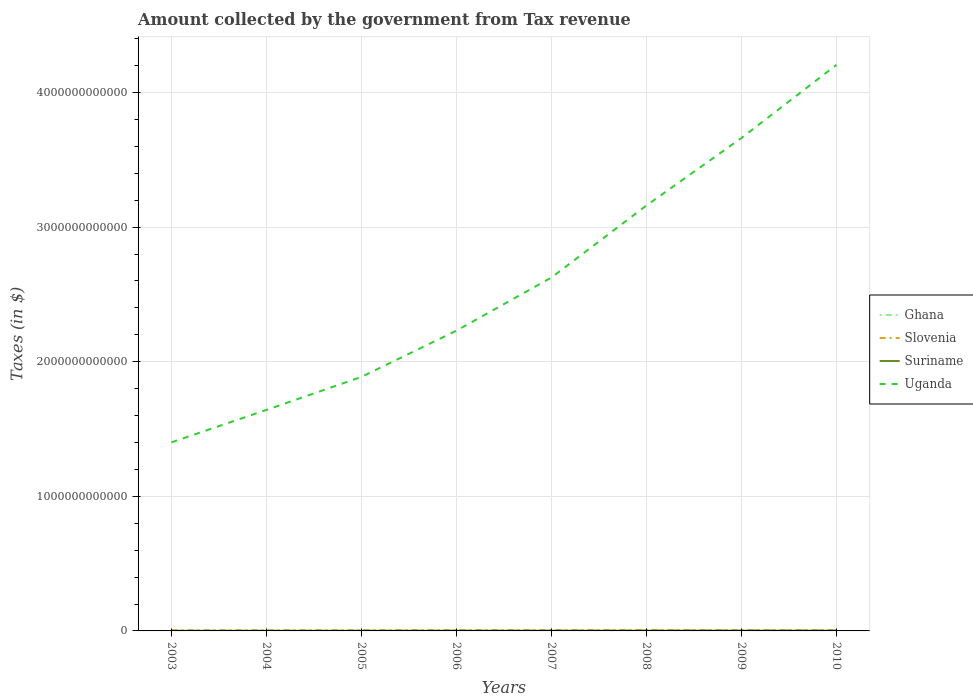Is the number of lines equal to the number of legend labels?
Give a very brief answer. Yes. Across all years, what is the maximum amount collected by the government from tax revenue in Suriname?
Make the answer very short. 7.12e+08. What is the total amount collected by the government from tax revenue in Slovenia in the graph?
Offer a terse response. -1.29e+09. What is the difference between the highest and the second highest amount collected by the government from tax revenue in Uganda?
Ensure brevity in your answer.  2.80e+12. How many years are there in the graph?
Give a very brief answer. 8. What is the difference between two consecutive major ticks on the Y-axis?
Your answer should be compact. 1.00e+12. Are the values on the major ticks of Y-axis written in scientific E-notation?
Offer a terse response. No. Does the graph contain grids?
Give a very brief answer. Yes. What is the title of the graph?
Keep it short and to the point. Amount collected by the government from Tax revenue. Does "Malta" appear as one of the legend labels in the graph?
Offer a terse response. No. What is the label or title of the X-axis?
Keep it short and to the point. Years. What is the label or title of the Y-axis?
Your answer should be very brief. Taxes (in $). What is the Taxes (in $) of Ghana in 2003?
Keep it short and to the point. 1.22e+09. What is the Taxes (in $) of Slovenia in 2003?
Your response must be concise. 5.23e+09. What is the Taxes (in $) of Suriname in 2003?
Provide a short and direct response. 7.12e+08. What is the Taxes (in $) of Uganda in 2003?
Make the answer very short. 1.40e+12. What is the Taxes (in $) in Ghana in 2004?
Provide a short and direct response. 1.74e+09. What is the Taxes (in $) of Slovenia in 2004?
Keep it short and to the point. 5.57e+09. What is the Taxes (in $) in Suriname in 2004?
Keep it short and to the point. 8.53e+08. What is the Taxes (in $) in Uganda in 2004?
Provide a succinct answer. 1.64e+12. What is the Taxes (in $) of Ghana in 2005?
Provide a short and direct response. 2.07e+09. What is the Taxes (in $) of Slovenia in 2005?
Make the answer very short. 5.90e+09. What is the Taxes (in $) of Suriname in 2005?
Your answer should be very brief. 1.01e+09. What is the Taxes (in $) of Uganda in 2005?
Make the answer very short. 1.89e+12. What is the Taxes (in $) of Ghana in 2006?
Your answer should be compact. 2.40e+09. What is the Taxes (in $) of Slovenia in 2006?
Make the answer very short. 6.52e+09. What is the Taxes (in $) of Suriname in 2006?
Provide a succinct answer. 1.21e+09. What is the Taxes (in $) of Uganda in 2006?
Your answer should be compact. 2.23e+12. What is the Taxes (in $) of Ghana in 2007?
Your response must be concise. 3.21e+09. What is the Taxes (in $) in Slovenia in 2007?
Keep it short and to the point. 6.79e+09. What is the Taxes (in $) in Suriname in 2007?
Ensure brevity in your answer.  1.52e+09. What is the Taxes (in $) of Uganda in 2007?
Ensure brevity in your answer.  2.63e+12. What is the Taxes (in $) of Ghana in 2008?
Ensure brevity in your answer.  4.19e+09. What is the Taxes (in $) of Slovenia in 2008?
Ensure brevity in your answer.  7.43e+09. What is the Taxes (in $) in Suriname in 2008?
Your answer should be very brief. 1.68e+09. What is the Taxes (in $) of Uganda in 2008?
Give a very brief answer. 3.16e+12. What is the Taxes (in $) of Ghana in 2009?
Provide a succinct answer. 4.62e+09. What is the Taxes (in $) of Slovenia in 2009?
Offer a terse response. 6.38e+09. What is the Taxes (in $) in Suriname in 2009?
Your answer should be compact. 1.83e+09. What is the Taxes (in $) in Uganda in 2009?
Give a very brief answer. 3.66e+12. What is the Taxes (in $) in Ghana in 2010?
Provide a short and direct response. 6.16e+09. What is the Taxes (in $) of Slovenia in 2010?
Provide a short and direct response. 6.07e+09. What is the Taxes (in $) of Suriname in 2010?
Offer a very short reply. 1.88e+09. What is the Taxes (in $) of Uganda in 2010?
Provide a succinct answer. 4.21e+12. Across all years, what is the maximum Taxes (in $) in Ghana?
Make the answer very short. 6.16e+09. Across all years, what is the maximum Taxes (in $) in Slovenia?
Give a very brief answer. 7.43e+09. Across all years, what is the maximum Taxes (in $) in Suriname?
Ensure brevity in your answer.  1.88e+09. Across all years, what is the maximum Taxes (in $) in Uganda?
Your response must be concise. 4.21e+12. Across all years, what is the minimum Taxes (in $) of Ghana?
Offer a terse response. 1.22e+09. Across all years, what is the minimum Taxes (in $) of Slovenia?
Offer a very short reply. 5.23e+09. Across all years, what is the minimum Taxes (in $) of Suriname?
Your answer should be compact. 7.12e+08. Across all years, what is the minimum Taxes (in $) in Uganda?
Keep it short and to the point. 1.40e+12. What is the total Taxes (in $) in Ghana in the graph?
Ensure brevity in your answer.  2.56e+1. What is the total Taxes (in $) of Slovenia in the graph?
Your response must be concise. 4.99e+1. What is the total Taxes (in $) of Suriname in the graph?
Your answer should be compact. 1.07e+1. What is the total Taxes (in $) of Uganda in the graph?
Offer a very short reply. 2.08e+13. What is the difference between the Taxes (in $) in Ghana in 2003 and that in 2004?
Your answer should be compact. -5.15e+08. What is the difference between the Taxes (in $) in Slovenia in 2003 and that in 2004?
Your answer should be very brief. -3.40e+08. What is the difference between the Taxes (in $) of Suriname in 2003 and that in 2004?
Keep it short and to the point. -1.41e+08. What is the difference between the Taxes (in $) of Uganda in 2003 and that in 2004?
Your answer should be compact. -2.41e+11. What is the difference between the Taxes (in $) of Ghana in 2003 and that in 2005?
Ensure brevity in your answer.  -8.51e+08. What is the difference between the Taxes (in $) of Slovenia in 2003 and that in 2005?
Give a very brief answer. -6.75e+08. What is the difference between the Taxes (in $) in Suriname in 2003 and that in 2005?
Your answer should be compact. -2.95e+08. What is the difference between the Taxes (in $) in Uganda in 2003 and that in 2005?
Offer a terse response. -4.86e+11. What is the difference between the Taxes (in $) in Ghana in 2003 and that in 2006?
Provide a short and direct response. -1.17e+09. What is the difference between the Taxes (in $) in Slovenia in 2003 and that in 2006?
Give a very brief answer. -1.29e+09. What is the difference between the Taxes (in $) in Suriname in 2003 and that in 2006?
Provide a short and direct response. -4.95e+08. What is the difference between the Taxes (in $) in Uganda in 2003 and that in 2006?
Your answer should be compact. -8.30e+11. What is the difference between the Taxes (in $) of Ghana in 2003 and that in 2007?
Give a very brief answer. -1.99e+09. What is the difference between the Taxes (in $) in Slovenia in 2003 and that in 2007?
Give a very brief answer. -1.57e+09. What is the difference between the Taxes (in $) of Suriname in 2003 and that in 2007?
Your response must be concise. -8.09e+08. What is the difference between the Taxes (in $) in Uganda in 2003 and that in 2007?
Your answer should be very brief. -1.22e+12. What is the difference between the Taxes (in $) in Ghana in 2003 and that in 2008?
Make the answer very short. -2.97e+09. What is the difference between the Taxes (in $) in Slovenia in 2003 and that in 2008?
Keep it short and to the point. -2.20e+09. What is the difference between the Taxes (in $) in Suriname in 2003 and that in 2008?
Offer a terse response. -9.70e+08. What is the difference between the Taxes (in $) of Uganda in 2003 and that in 2008?
Give a very brief answer. -1.76e+12. What is the difference between the Taxes (in $) of Ghana in 2003 and that in 2009?
Your answer should be compact. -3.39e+09. What is the difference between the Taxes (in $) of Slovenia in 2003 and that in 2009?
Keep it short and to the point. -1.16e+09. What is the difference between the Taxes (in $) in Suriname in 2003 and that in 2009?
Your answer should be compact. -1.12e+09. What is the difference between the Taxes (in $) of Uganda in 2003 and that in 2009?
Ensure brevity in your answer.  -2.26e+12. What is the difference between the Taxes (in $) in Ghana in 2003 and that in 2010?
Keep it short and to the point. -4.94e+09. What is the difference between the Taxes (in $) of Slovenia in 2003 and that in 2010?
Your response must be concise. -8.41e+08. What is the difference between the Taxes (in $) in Suriname in 2003 and that in 2010?
Offer a very short reply. -1.17e+09. What is the difference between the Taxes (in $) in Uganda in 2003 and that in 2010?
Provide a short and direct response. -2.80e+12. What is the difference between the Taxes (in $) in Ghana in 2004 and that in 2005?
Make the answer very short. -3.36e+08. What is the difference between the Taxes (in $) in Slovenia in 2004 and that in 2005?
Give a very brief answer. -3.34e+08. What is the difference between the Taxes (in $) in Suriname in 2004 and that in 2005?
Offer a terse response. -1.54e+08. What is the difference between the Taxes (in $) of Uganda in 2004 and that in 2005?
Your answer should be compact. -2.45e+11. What is the difference between the Taxes (in $) in Ghana in 2004 and that in 2006?
Give a very brief answer. -6.58e+08. What is the difference between the Taxes (in $) of Slovenia in 2004 and that in 2006?
Your answer should be very brief. -9.53e+08. What is the difference between the Taxes (in $) in Suriname in 2004 and that in 2006?
Provide a short and direct response. -3.54e+08. What is the difference between the Taxes (in $) of Uganda in 2004 and that in 2006?
Provide a succinct answer. -5.89e+11. What is the difference between the Taxes (in $) in Ghana in 2004 and that in 2007?
Make the answer very short. -1.48e+09. What is the difference between the Taxes (in $) in Slovenia in 2004 and that in 2007?
Ensure brevity in your answer.  -1.23e+09. What is the difference between the Taxes (in $) in Suriname in 2004 and that in 2007?
Your answer should be very brief. -6.68e+08. What is the difference between the Taxes (in $) of Uganda in 2004 and that in 2007?
Provide a succinct answer. -9.84e+11. What is the difference between the Taxes (in $) in Ghana in 2004 and that in 2008?
Provide a succinct answer. -2.46e+09. What is the difference between the Taxes (in $) in Slovenia in 2004 and that in 2008?
Offer a terse response. -1.86e+09. What is the difference between the Taxes (in $) in Suriname in 2004 and that in 2008?
Make the answer very short. -8.29e+08. What is the difference between the Taxes (in $) of Uganda in 2004 and that in 2008?
Keep it short and to the point. -1.52e+12. What is the difference between the Taxes (in $) in Ghana in 2004 and that in 2009?
Ensure brevity in your answer.  -2.88e+09. What is the difference between the Taxes (in $) of Slovenia in 2004 and that in 2009?
Your response must be concise. -8.16e+08. What is the difference between the Taxes (in $) in Suriname in 2004 and that in 2009?
Your response must be concise. -9.79e+08. What is the difference between the Taxes (in $) of Uganda in 2004 and that in 2009?
Offer a very short reply. -2.02e+12. What is the difference between the Taxes (in $) of Ghana in 2004 and that in 2010?
Provide a succinct answer. -4.43e+09. What is the difference between the Taxes (in $) of Slovenia in 2004 and that in 2010?
Your answer should be compact. -5.00e+08. What is the difference between the Taxes (in $) in Suriname in 2004 and that in 2010?
Ensure brevity in your answer.  -1.02e+09. What is the difference between the Taxes (in $) in Uganda in 2004 and that in 2010?
Ensure brevity in your answer.  -2.56e+12. What is the difference between the Taxes (in $) in Ghana in 2005 and that in 2006?
Your response must be concise. -3.22e+08. What is the difference between the Taxes (in $) in Slovenia in 2005 and that in 2006?
Give a very brief answer. -6.18e+08. What is the difference between the Taxes (in $) of Suriname in 2005 and that in 2006?
Offer a very short reply. -2.00e+08. What is the difference between the Taxes (in $) in Uganda in 2005 and that in 2006?
Provide a short and direct response. -3.44e+11. What is the difference between the Taxes (in $) of Ghana in 2005 and that in 2007?
Provide a short and direct response. -1.14e+09. What is the difference between the Taxes (in $) in Slovenia in 2005 and that in 2007?
Ensure brevity in your answer.  -8.91e+08. What is the difference between the Taxes (in $) of Suriname in 2005 and that in 2007?
Your answer should be very brief. -5.14e+08. What is the difference between the Taxes (in $) of Uganda in 2005 and that in 2007?
Make the answer very short. -7.38e+11. What is the difference between the Taxes (in $) in Ghana in 2005 and that in 2008?
Provide a succinct answer. -2.12e+09. What is the difference between the Taxes (in $) of Slovenia in 2005 and that in 2008?
Your answer should be very brief. -1.53e+09. What is the difference between the Taxes (in $) in Suriname in 2005 and that in 2008?
Give a very brief answer. -6.76e+08. What is the difference between the Taxes (in $) of Uganda in 2005 and that in 2008?
Ensure brevity in your answer.  -1.27e+12. What is the difference between the Taxes (in $) in Ghana in 2005 and that in 2009?
Offer a terse response. -2.54e+09. What is the difference between the Taxes (in $) of Slovenia in 2005 and that in 2009?
Make the answer very short. -4.81e+08. What is the difference between the Taxes (in $) in Suriname in 2005 and that in 2009?
Keep it short and to the point. -8.25e+08. What is the difference between the Taxes (in $) of Uganda in 2005 and that in 2009?
Keep it short and to the point. -1.77e+12. What is the difference between the Taxes (in $) of Ghana in 2005 and that in 2010?
Keep it short and to the point. -4.09e+09. What is the difference between the Taxes (in $) of Slovenia in 2005 and that in 2010?
Offer a terse response. -1.66e+08. What is the difference between the Taxes (in $) in Suriname in 2005 and that in 2010?
Provide a succinct answer. -8.71e+08. What is the difference between the Taxes (in $) of Uganda in 2005 and that in 2010?
Ensure brevity in your answer.  -2.32e+12. What is the difference between the Taxes (in $) in Ghana in 2006 and that in 2007?
Offer a terse response. -8.18e+08. What is the difference between the Taxes (in $) of Slovenia in 2006 and that in 2007?
Your response must be concise. -2.73e+08. What is the difference between the Taxes (in $) in Suriname in 2006 and that in 2007?
Your answer should be very brief. -3.14e+08. What is the difference between the Taxes (in $) in Uganda in 2006 and that in 2007?
Your answer should be very brief. -3.95e+11. What is the difference between the Taxes (in $) of Ghana in 2006 and that in 2008?
Make the answer very short. -1.80e+09. What is the difference between the Taxes (in $) of Slovenia in 2006 and that in 2008?
Offer a terse response. -9.12e+08. What is the difference between the Taxes (in $) of Suriname in 2006 and that in 2008?
Give a very brief answer. -4.76e+08. What is the difference between the Taxes (in $) in Uganda in 2006 and that in 2008?
Your answer should be compact. -9.30e+11. What is the difference between the Taxes (in $) in Ghana in 2006 and that in 2009?
Keep it short and to the point. -2.22e+09. What is the difference between the Taxes (in $) of Slovenia in 2006 and that in 2009?
Provide a short and direct response. 1.37e+08. What is the difference between the Taxes (in $) of Suriname in 2006 and that in 2009?
Give a very brief answer. -6.25e+08. What is the difference between the Taxes (in $) of Uganda in 2006 and that in 2009?
Ensure brevity in your answer.  -1.43e+12. What is the difference between the Taxes (in $) of Ghana in 2006 and that in 2010?
Your answer should be compact. -3.77e+09. What is the difference between the Taxes (in $) of Slovenia in 2006 and that in 2010?
Your answer should be very brief. 4.52e+08. What is the difference between the Taxes (in $) of Suriname in 2006 and that in 2010?
Offer a terse response. -6.71e+08. What is the difference between the Taxes (in $) in Uganda in 2006 and that in 2010?
Your response must be concise. -1.97e+12. What is the difference between the Taxes (in $) of Ghana in 2007 and that in 2008?
Your answer should be compact. -9.80e+08. What is the difference between the Taxes (in $) of Slovenia in 2007 and that in 2008?
Give a very brief answer. -6.39e+08. What is the difference between the Taxes (in $) of Suriname in 2007 and that in 2008?
Your answer should be compact. -1.62e+08. What is the difference between the Taxes (in $) of Uganda in 2007 and that in 2008?
Offer a terse response. -5.35e+11. What is the difference between the Taxes (in $) of Ghana in 2007 and that in 2009?
Your answer should be very brief. -1.40e+09. What is the difference between the Taxes (in $) of Slovenia in 2007 and that in 2009?
Make the answer very short. 4.10e+08. What is the difference between the Taxes (in $) in Suriname in 2007 and that in 2009?
Ensure brevity in your answer.  -3.11e+08. What is the difference between the Taxes (in $) in Uganda in 2007 and that in 2009?
Offer a terse response. -1.04e+12. What is the difference between the Taxes (in $) in Ghana in 2007 and that in 2010?
Your response must be concise. -2.95e+09. What is the difference between the Taxes (in $) of Slovenia in 2007 and that in 2010?
Make the answer very short. 7.25e+08. What is the difference between the Taxes (in $) of Suriname in 2007 and that in 2010?
Your answer should be very brief. -3.57e+08. What is the difference between the Taxes (in $) of Uganda in 2007 and that in 2010?
Your answer should be compact. -1.58e+12. What is the difference between the Taxes (in $) in Ghana in 2008 and that in 2009?
Provide a succinct answer. -4.22e+08. What is the difference between the Taxes (in $) in Slovenia in 2008 and that in 2009?
Your answer should be very brief. 1.05e+09. What is the difference between the Taxes (in $) in Suriname in 2008 and that in 2009?
Offer a terse response. -1.49e+08. What is the difference between the Taxes (in $) in Uganda in 2008 and that in 2009?
Your response must be concise. -5.01e+11. What is the difference between the Taxes (in $) of Ghana in 2008 and that in 2010?
Ensure brevity in your answer.  -1.97e+09. What is the difference between the Taxes (in $) of Slovenia in 2008 and that in 2010?
Your response must be concise. 1.36e+09. What is the difference between the Taxes (in $) in Suriname in 2008 and that in 2010?
Your answer should be compact. -1.95e+08. What is the difference between the Taxes (in $) of Uganda in 2008 and that in 2010?
Give a very brief answer. -1.04e+12. What is the difference between the Taxes (in $) in Ghana in 2009 and that in 2010?
Give a very brief answer. -1.55e+09. What is the difference between the Taxes (in $) in Slovenia in 2009 and that in 2010?
Your answer should be compact. 3.15e+08. What is the difference between the Taxes (in $) of Suriname in 2009 and that in 2010?
Your answer should be compact. -4.60e+07. What is the difference between the Taxes (in $) of Uganda in 2009 and that in 2010?
Keep it short and to the point. -5.43e+11. What is the difference between the Taxes (in $) in Ghana in 2003 and the Taxes (in $) in Slovenia in 2004?
Offer a terse response. -4.34e+09. What is the difference between the Taxes (in $) in Ghana in 2003 and the Taxes (in $) in Suriname in 2004?
Give a very brief answer. 3.69e+08. What is the difference between the Taxes (in $) in Ghana in 2003 and the Taxes (in $) in Uganda in 2004?
Your answer should be very brief. -1.64e+12. What is the difference between the Taxes (in $) of Slovenia in 2003 and the Taxes (in $) of Suriname in 2004?
Offer a terse response. 4.37e+09. What is the difference between the Taxes (in $) of Slovenia in 2003 and the Taxes (in $) of Uganda in 2004?
Your response must be concise. -1.64e+12. What is the difference between the Taxes (in $) in Suriname in 2003 and the Taxes (in $) in Uganda in 2004?
Offer a very short reply. -1.64e+12. What is the difference between the Taxes (in $) of Ghana in 2003 and the Taxes (in $) of Slovenia in 2005?
Keep it short and to the point. -4.68e+09. What is the difference between the Taxes (in $) in Ghana in 2003 and the Taxes (in $) in Suriname in 2005?
Your answer should be compact. 2.16e+08. What is the difference between the Taxes (in $) of Ghana in 2003 and the Taxes (in $) of Uganda in 2005?
Ensure brevity in your answer.  -1.89e+12. What is the difference between the Taxes (in $) in Slovenia in 2003 and the Taxes (in $) in Suriname in 2005?
Give a very brief answer. 4.22e+09. What is the difference between the Taxes (in $) in Slovenia in 2003 and the Taxes (in $) in Uganda in 2005?
Keep it short and to the point. -1.88e+12. What is the difference between the Taxes (in $) in Suriname in 2003 and the Taxes (in $) in Uganda in 2005?
Ensure brevity in your answer.  -1.89e+12. What is the difference between the Taxes (in $) in Ghana in 2003 and the Taxes (in $) in Slovenia in 2006?
Your answer should be compact. -5.30e+09. What is the difference between the Taxes (in $) in Ghana in 2003 and the Taxes (in $) in Suriname in 2006?
Ensure brevity in your answer.  1.55e+07. What is the difference between the Taxes (in $) of Ghana in 2003 and the Taxes (in $) of Uganda in 2006?
Offer a very short reply. -2.23e+12. What is the difference between the Taxes (in $) in Slovenia in 2003 and the Taxes (in $) in Suriname in 2006?
Provide a succinct answer. 4.02e+09. What is the difference between the Taxes (in $) of Slovenia in 2003 and the Taxes (in $) of Uganda in 2006?
Ensure brevity in your answer.  -2.23e+12. What is the difference between the Taxes (in $) in Suriname in 2003 and the Taxes (in $) in Uganda in 2006?
Offer a terse response. -2.23e+12. What is the difference between the Taxes (in $) of Ghana in 2003 and the Taxes (in $) of Slovenia in 2007?
Your response must be concise. -5.57e+09. What is the difference between the Taxes (in $) of Ghana in 2003 and the Taxes (in $) of Suriname in 2007?
Provide a short and direct response. -2.98e+08. What is the difference between the Taxes (in $) in Ghana in 2003 and the Taxes (in $) in Uganda in 2007?
Give a very brief answer. -2.62e+12. What is the difference between the Taxes (in $) of Slovenia in 2003 and the Taxes (in $) of Suriname in 2007?
Your answer should be compact. 3.70e+09. What is the difference between the Taxes (in $) of Slovenia in 2003 and the Taxes (in $) of Uganda in 2007?
Provide a short and direct response. -2.62e+12. What is the difference between the Taxes (in $) of Suriname in 2003 and the Taxes (in $) of Uganda in 2007?
Your answer should be very brief. -2.63e+12. What is the difference between the Taxes (in $) in Ghana in 2003 and the Taxes (in $) in Slovenia in 2008?
Make the answer very short. -6.21e+09. What is the difference between the Taxes (in $) of Ghana in 2003 and the Taxes (in $) of Suriname in 2008?
Make the answer very short. -4.60e+08. What is the difference between the Taxes (in $) of Ghana in 2003 and the Taxes (in $) of Uganda in 2008?
Offer a terse response. -3.16e+12. What is the difference between the Taxes (in $) of Slovenia in 2003 and the Taxes (in $) of Suriname in 2008?
Make the answer very short. 3.54e+09. What is the difference between the Taxes (in $) of Slovenia in 2003 and the Taxes (in $) of Uganda in 2008?
Offer a terse response. -3.16e+12. What is the difference between the Taxes (in $) of Suriname in 2003 and the Taxes (in $) of Uganda in 2008?
Offer a very short reply. -3.16e+12. What is the difference between the Taxes (in $) of Ghana in 2003 and the Taxes (in $) of Slovenia in 2009?
Offer a very short reply. -5.16e+09. What is the difference between the Taxes (in $) of Ghana in 2003 and the Taxes (in $) of Suriname in 2009?
Provide a succinct answer. -6.09e+08. What is the difference between the Taxes (in $) of Ghana in 2003 and the Taxes (in $) of Uganda in 2009?
Offer a very short reply. -3.66e+12. What is the difference between the Taxes (in $) in Slovenia in 2003 and the Taxes (in $) in Suriname in 2009?
Provide a succinct answer. 3.39e+09. What is the difference between the Taxes (in $) of Slovenia in 2003 and the Taxes (in $) of Uganda in 2009?
Make the answer very short. -3.66e+12. What is the difference between the Taxes (in $) in Suriname in 2003 and the Taxes (in $) in Uganda in 2009?
Your answer should be very brief. -3.66e+12. What is the difference between the Taxes (in $) in Ghana in 2003 and the Taxes (in $) in Slovenia in 2010?
Make the answer very short. -4.84e+09. What is the difference between the Taxes (in $) in Ghana in 2003 and the Taxes (in $) in Suriname in 2010?
Your answer should be very brief. -6.55e+08. What is the difference between the Taxes (in $) of Ghana in 2003 and the Taxes (in $) of Uganda in 2010?
Make the answer very short. -4.20e+12. What is the difference between the Taxes (in $) of Slovenia in 2003 and the Taxes (in $) of Suriname in 2010?
Your answer should be compact. 3.35e+09. What is the difference between the Taxes (in $) in Slovenia in 2003 and the Taxes (in $) in Uganda in 2010?
Give a very brief answer. -4.20e+12. What is the difference between the Taxes (in $) in Suriname in 2003 and the Taxes (in $) in Uganda in 2010?
Provide a short and direct response. -4.20e+12. What is the difference between the Taxes (in $) of Ghana in 2004 and the Taxes (in $) of Slovenia in 2005?
Keep it short and to the point. -4.16e+09. What is the difference between the Taxes (in $) in Ghana in 2004 and the Taxes (in $) in Suriname in 2005?
Offer a terse response. 7.31e+08. What is the difference between the Taxes (in $) of Ghana in 2004 and the Taxes (in $) of Uganda in 2005?
Make the answer very short. -1.89e+12. What is the difference between the Taxes (in $) of Slovenia in 2004 and the Taxes (in $) of Suriname in 2005?
Provide a succinct answer. 4.56e+09. What is the difference between the Taxes (in $) of Slovenia in 2004 and the Taxes (in $) of Uganda in 2005?
Offer a very short reply. -1.88e+12. What is the difference between the Taxes (in $) in Suriname in 2004 and the Taxes (in $) in Uganda in 2005?
Give a very brief answer. -1.89e+12. What is the difference between the Taxes (in $) of Ghana in 2004 and the Taxes (in $) of Slovenia in 2006?
Make the answer very short. -4.78e+09. What is the difference between the Taxes (in $) in Ghana in 2004 and the Taxes (in $) in Suriname in 2006?
Ensure brevity in your answer.  5.31e+08. What is the difference between the Taxes (in $) in Ghana in 2004 and the Taxes (in $) in Uganda in 2006?
Your answer should be compact. -2.23e+12. What is the difference between the Taxes (in $) in Slovenia in 2004 and the Taxes (in $) in Suriname in 2006?
Provide a succinct answer. 4.36e+09. What is the difference between the Taxes (in $) of Slovenia in 2004 and the Taxes (in $) of Uganda in 2006?
Your answer should be very brief. -2.23e+12. What is the difference between the Taxes (in $) of Suriname in 2004 and the Taxes (in $) of Uganda in 2006?
Make the answer very short. -2.23e+12. What is the difference between the Taxes (in $) of Ghana in 2004 and the Taxes (in $) of Slovenia in 2007?
Give a very brief answer. -5.05e+09. What is the difference between the Taxes (in $) in Ghana in 2004 and the Taxes (in $) in Suriname in 2007?
Your response must be concise. 2.17e+08. What is the difference between the Taxes (in $) in Ghana in 2004 and the Taxes (in $) in Uganda in 2007?
Provide a succinct answer. -2.62e+12. What is the difference between the Taxes (in $) of Slovenia in 2004 and the Taxes (in $) of Suriname in 2007?
Provide a short and direct response. 4.04e+09. What is the difference between the Taxes (in $) of Slovenia in 2004 and the Taxes (in $) of Uganda in 2007?
Give a very brief answer. -2.62e+12. What is the difference between the Taxes (in $) in Suriname in 2004 and the Taxes (in $) in Uganda in 2007?
Your answer should be very brief. -2.62e+12. What is the difference between the Taxes (in $) of Ghana in 2004 and the Taxes (in $) of Slovenia in 2008?
Make the answer very short. -5.69e+09. What is the difference between the Taxes (in $) in Ghana in 2004 and the Taxes (in $) in Suriname in 2008?
Your answer should be very brief. 5.52e+07. What is the difference between the Taxes (in $) of Ghana in 2004 and the Taxes (in $) of Uganda in 2008?
Offer a terse response. -3.16e+12. What is the difference between the Taxes (in $) of Slovenia in 2004 and the Taxes (in $) of Suriname in 2008?
Your answer should be compact. 3.88e+09. What is the difference between the Taxes (in $) in Slovenia in 2004 and the Taxes (in $) in Uganda in 2008?
Provide a short and direct response. -3.16e+12. What is the difference between the Taxes (in $) of Suriname in 2004 and the Taxes (in $) of Uganda in 2008?
Your response must be concise. -3.16e+12. What is the difference between the Taxes (in $) of Ghana in 2004 and the Taxes (in $) of Slovenia in 2009?
Provide a short and direct response. -4.64e+09. What is the difference between the Taxes (in $) of Ghana in 2004 and the Taxes (in $) of Suriname in 2009?
Give a very brief answer. -9.40e+07. What is the difference between the Taxes (in $) in Ghana in 2004 and the Taxes (in $) in Uganda in 2009?
Your answer should be compact. -3.66e+12. What is the difference between the Taxes (in $) in Slovenia in 2004 and the Taxes (in $) in Suriname in 2009?
Provide a succinct answer. 3.73e+09. What is the difference between the Taxes (in $) in Slovenia in 2004 and the Taxes (in $) in Uganda in 2009?
Your response must be concise. -3.66e+12. What is the difference between the Taxes (in $) in Suriname in 2004 and the Taxes (in $) in Uganda in 2009?
Offer a very short reply. -3.66e+12. What is the difference between the Taxes (in $) of Ghana in 2004 and the Taxes (in $) of Slovenia in 2010?
Your answer should be compact. -4.33e+09. What is the difference between the Taxes (in $) of Ghana in 2004 and the Taxes (in $) of Suriname in 2010?
Your answer should be very brief. -1.40e+08. What is the difference between the Taxes (in $) in Ghana in 2004 and the Taxes (in $) in Uganda in 2010?
Keep it short and to the point. -4.20e+12. What is the difference between the Taxes (in $) in Slovenia in 2004 and the Taxes (in $) in Suriname in 2010?
Your answer should be very brief. 3.69e+09. What is the difference between the Taxes (in $) in Slovenia in 2004 and the Taxes (in $) in Uganda in 2010?
Offer a terse response. -4.20e+12. What is the difference between the Taxes (in $) in Suriname in 2004 and the Taxes (in $) in Uganda in 2010?
Ensure brevity in your answer.  -4.20e+12. What is the difference between the Taxes (in $) of Ghana in 2005 and the Taxes (in $) of Slovenia in 2006?
Your answer should be very brief. -4.44e+09. What is the difference between the Taxes (in $) of Ghana in 2005 and the Taxes (in $) of Suriname in 2006?
Make the answer very short. 8.67e+08. What is the difference between the Taxes (in $) in Ghana in 2005 and the Taxes (in $) in Uganda in 2006?
Provide a succinct answer. -2.23e+12. What is the difference between the Taxes (in $) in Slovenia in 2005 and the Taxes (in $) in Suriname in 2006?
Ensure brevity in your answer.  4.69e+09. What is the difference between the Taxes (in $) of Slovenia in 2005 and the Taxes (in $) of Uganda in 2006?
Keep it short and to the point. -2.23e+12. What is the difference between the Taxes (in $) of Suriname in 2005 and the Taxes (in $) of Uganda in 2006?
Provide a short and direct response. -2.23e+12. What is the difference between the Taxes (in $) in Ghana in 2005 and the Taxes (in $) in Slovenia in 2007?
Your answer should be very brief. -4.72e+09. What is the difference between the Taxes (in $) of Ghana in 2005 and the Taxes (in $) of Suriname in 2007?
Your answer should be compact. 5.53e+08. What is the difference between the Taxes (in $) of Ghana in 2005 and the Taxes (in $) of Uganda in 2007?
Keep it short and to the point. -2.62e+12. What is the difference between the Taxes (in $) of Slovenia in 2005 and the Taxes (in $) of Suriname in 2007?
Keep it short and to the point. 4.38e+09. What is the difference between the Taxes (in $) of Slovenia in 2005 and the Taxes (in $) of Uganda in 2007?
Offer a terse response. -2.62e+12. What is the difference between the Taxes (in $) of Suriname in 2005 and the Taxes (in $) of Uganda in 2007?
Offer a terse response. -2.62e+12. What is the difference between the Taxes (in $) of Ghana in 2005 and the Taxes (in $) of Slovenia in 2008?
Offer a terse response. -5.36e+09. What is the difference between the Taxes (in $) of Ghana in 2005 and the Taxes (in $) of Suriname in 2008?
Keep it short and to the point. 3.91e+08. What is the difference between the Taxes (in $) of Ghana in 2005 and the Taxes (in $) of Uganda in 2008?
Your answer should be compact. -3.16e+12. What is the difference between the Taxes (in $) of Slovenia in 2005 and the Taxes (in $) of Suriname in 2008?
Offer a very short reply. 4.22e+09. What is the difference between the Taxes (in $) of Slovenia in 2005 and the Taxes (in $) of Uganda in 2008?
Keep it short and to the point. -3.16e+12. What is the difference between the Taxes (in $) of Suriname in 2005 and the Taxes (in $) of Uganda in 2008?
Give a very brief answer. -3.16e+12. What is the difference between the Taxes (in $) of Ghana in 2005 and the Taxes (in $) of Slovenia in 2009?
Your answer should be compact. -4.31e+09. What is the difference between the Taxes (in $) of Ghana in 2005 and the Taxes (in $) of Suriname in 2009?
Your answer should be compact. 2.42e+08. What is the difference between the Taxes (in $) in Ghana in 2005 and the Taxes (in $) in Uganda in 2009?
Keep it short and to the point. -3.66e+12. What is the difference between the Taxes (in $) of Slovenia in 2005 and the Taxes (in $) of Suriname in 2009?
Offer a very short reply. 4.07e+09. What is the difference between the Taxes (in $) of Slovenia in 2005 and the Taxes (in $) of Uganda in 2009?
Make the answer very short. -3.66e+12. What is the difference between the Taxes (in $) of Suriname in 2005 and the Taxes (in $) of Uganda in 2009?
Provide a short and direct response. -3.66e+12. What is the difference between the Taxes (in $) of Ghana in 2005 and the Taxes (in $) of Slovenia in 2010?
Your answer should be very brief. -3.99e+09. What is the difference between the Taxes (in $) of Ghana in 2005 and the Taxes (in $) of Suriname in 2010?
Provide a succinct answer. 1.96e+08. What is the difference between the Taxes (in $) in Ghana in 2005 and the Taxes (in $) in Uganda in 2010?
Your answer should be compact. -4.20e+12. What is the difference between the Taxes (in $) in Slovenia in 2005 and the Taxes (in $) in Suriname in 2010?
Offer a terse response. 4.02e+09. What is the difference between the Taxes (in $) in Slovenia in 2005 and the Taxes (in $) in Uganda in 2010?
Provide a short and direct response. -4.20e+12. What is the difference between the Taxes (in $) of Suriname in 2005 and the Taxes (in $) of Uganda in 2010?
Make the answer very short. -4.20e+12. What is the difference between the Taxes (in $) in Ghana in 2006 and the Taxes (in $) in Slovenia in 2007?
Offer a very short reply. -4.40e+09. What is the difference between the Taxes (in $) in Ghana in 2006 and the Taxes (in $) in Suriname in 2007?
Give a very brief answer. 8.75e+08. What is the difference between the Taxes (in $) of Ghana in 2006 and the Taxes (in $) of Uganda in 2007?
Offer a terse response. -2.62e+12. What is the difference between the Taxes (in $) in Slovenia in 2006 and the Taxes (in $) in Suriname in 2007?
Make the answer very short. 5.00e+09. What is the difference between the Taxes (in $) in Slovenia in 2006 and the Taxes (in $) in Uganda in 2007?
Offer a very short reply. -2.62e+12. What is the difference between the Taxes (in $) of Suriname in 2006 and the Taxes (in $) of Uganda in 2007?
Keep it short and to the point. -2.62e+12. What is the difference between the Taxes (in $) in Ghana in 2006 and the Taxes (in $) in Slovenia in 2008?
Give a very brief answer. -5.03e+09. What is the difference between the Taxes (in $) in Ghana in 2006 and the Taxes (in $) in Suriname in 2008?
Provide a short and direct response. 7.13e+08. What is the difference between the Taxes (in $) of Ghana in 2006 and the Taxes (in $) of Uganda in 2008?
Offer a terse response. -3.16e+12. What is the difference between the Taxes (in $) of Slovenia in 2006 and the Taxes (in $) of Suriname in 2008?
Ensure brevity in your answer.  4.84e+09. What is the difference between the Taxes (in $) of Slovenia in 2006 and the Taxes (in $) of Uganda in 2008?
Your answer should be very brief. -3.15e+12. What is the difference between the Taxes (in $) of Suriname in 2006 and the Taxes (in $) of Uganda in 2008?
Keep it short and to the point. -3.16e+12. What is the difference between the Taxes (in $) of Ghana in 2006 and the Taxes (in $) of Slovenia in 2009?
Provide a short and direct response. -3.99e+09. What is the difference between the Taxes (in $) of Ghana in 2006 and the Taxes (in $) of Suriname in 2009?
Your answer should be very brief. 5.64e+08. What is the difference between the Taxes (in $) of Ghana in 2006 and the Taxes (in $) of Uganda in 2009?
Give a very brief answer. -3.66e+12. What is the difference between the Taxes (in $) in Slovenia in 2006 and the Taxes (in $) in Suriname in 2009?
Offer a terse response. 4.69e+09. What is the difference between the Taxes (in $) of Slovenia in 2006 and the Taxes (in $) of Uganda in 2009?
Provide a short and direct response. -3.66e+12. What is the difference between the Taxes (in $) in Suriname in 2006 and the Taxes (in $) in Uganda in 2009?
Provide a short and direct response. -3.66e+12. What is the difference between the Taxes (in $) in Ghana in 2006 and the Taxes (in $) in Slovenia in 2010?
Provide a short and direct response. -3.67e+09. What is the difference between the Taxes (in $) in Ghana in 2006 and the Taxes (in $) in Suriname in 2010?
Ensure brevity in your answer.  5.18e+08. What is the difference between the Taxes (in $) of Ghana in 2006 and the Taxes (in $) of Uganda in 2010?
Provide a short and direct response. -4.20e+12. What is the difference between the Taxes (in $) in Slovenia in 2006 and the Taxes (in $) in Suriname in 2010?
Your answer should be compact. 4.64e+09. What is the difference between the Taxes (in $) in Slovenia in 2006 and the Taxes (in $) in Uganda in 2010?
Provide a succinct answer. -4.20e+12. What is the difference between the Taxes (in $) of Suriname in 2006 and the Taxes (in $) of Uganda in 2010?
Make the answer very short. -4.20e+12. What is the difference between the Taxes (in $) of Ghana in 2007 and the Taxes (in $) of Slovenia in 2008?
Offer a terse response. -4.22e+09. What is the difference between the Taxes (in $) in Ghana in 2007 and the Taxes (in $) in Suriname in 2008?
Give a very brief answer. 1.53e+09. What is the difference between the Taxes (in $) of Ghana in 2007 and the Taxes (in $) of Uganda in 2008?
Your response must be concise. -3.16e+12. What is the difference between the Taxes (in $) in Slovenia in 2007 and the Taxes (in $) in Suriname in 2008?
Offer a terse response. 5.11e+09. What is the difference between the Taxes (in $) of Slovenia in 2007 and the Taxes (in $) of Uganda in 2008?
Make the answer very short. -3.15e+12. What is the difference between the Taxes (in $) of Suriname in 2007 and the Taxes (in $) of Uganda in 2008?
Provide a succinct answer. -3.16e+12. What is the difference between the Taxes (in $) in Ghana in 2007 and the Taxes (in $) in Slovenia in 2009?
Provide a succinct answer. -3.17e+09. What is the difference between the Taxes (in $) in Ghana in 2007 and the Taxes (in $) in Suriname in 2009?
Provide a succinct answer. 1.38e+09. What is the difference between the Taxes (in $) of Ghana in 2007 and the Taxes (in $) of Uganda in 2009?
Keep it short and to the point. -3.66e+12. What is the difference between the Taxes (in $) of Slovenia in 2007 and the Taxes (in $) of Suriname in 2009?
Give a very brief answer. 4.96e+09. What is the difference between the Taxes (in $) in Slovenia in 2007 and the Taxes (in $) in Uganda in 2009?
Provide a short and direct response. -3.66e+12. What is the difference between the Taxes (in $) of Suriname in 2007 and the Taxes (in $) of Uganda in 2009?
Provide a succinct answer. -3.66e+12. What is the difference between the Taxes (in $) of Ghana in 2007 and the Taxes (in $) of Slovenia in 2010?
Provide a succinct answer. -2.85e+09. What is the difference between the Taxes (in $) of Ghana in 2007 and the Taxes (in $) of Suriname in 2010?
Your answer should be compact. 1.34e+09. What is the difference between the Taxes (in $) in Ghana in 2007 and the Taxes (in $) in Uganda in 2010?
Make the answer very short. -4.20e+12. What is the difference between the Taxes (in $) in Slovenia in 2007 and the Taxes (in $) in Suriname in 2010?
Offer a very short reply. 4.91e+09. What is the difference between the Taxes (in $) in Slovenia in 2007 and the Taxes (in $) in Uganda in 2010?
Offer a very short reply. -4.20e+12. What is the difference between the Taxes (in $) in Suriname in 2007 and the Taxes (in $) in Uganda in 2010?
Ensure brevity in your answer.  -4.20e+12. What is the difference between the Taxes (in $) in Ghana in 2008 and the Taxes (in $) in Slovenia in 2009?
Provide a succinct answer. -2.19e+09. What is the difference between the Taxes (in $) in Ghana in 2008 and the Taxes (in $) in Suriname in 2009?
Keep it short and to the point. 2.36e+09. What is the difference between the Taxes (in $) of Ghana in 2008 and the Taxes (in $) of Uganda in 2009?
Make the answer very short. -3.66e+12. What is the difference between the Taxes (in $) in Slovenia in 2008 and the Taxes (in $) in Suriname in 2009?
Your answer should be very brief. 5.60e+09. What is the difference between the Taxes (in $) in Slovenia in 2008 and the Taxes (in $) in Uganda in 2009?
Provide a short and direct response. -3.65e+12. What is the difference between the Taxes (in $) in Suriname in 2008 and the Taxes (in $) in Uganda in 2009?
Provide a short and direct response. -3.66e+12. What is the difference between the Taxes (in $) in Ghana in 2008 and the Taxes (in $) in Slovenia in 2010?
Your answer should be very brief. -1.87e+09. What is the difference between the Taxes (in $) in Ghana in 2008 and the Taxes (in $) in Suriname in 2010?
Make the answer very short. 2.32e+09. What is the difference between the Taxes (in $) in Ghana in 2008 and the Taxes (in $) in Uganda in 2010?
Give a very brief answer. -4.20e+12. What is the difference between the Taxes (in $) of Slovenia in 2008 and the Taxes (in $) of Suriname in 2010?
Ensure brevity in your answer.  5.55e+09. What is the difference between the Taxes (in $) of Slovenia in 2008 and the Taxes (in $) of Uganda in 2010?
Keep it short and to the point. -4.20e+12. What is the difference between the Taxes (in $) of Suriname in 2008 and the Taxes (in $) of Uganda in 2010?
Your response must be concise. -4.20e+12. What is the difference between the Taxes (in $) in Ghana in 2009 and the Taxes (in $) in Slovenia in 2010?
Ensure brevity in your answer.  -1.45e+09. What is the difference between the Taxes (in $) of Ghana in 2009 and the Taxes (in $) of Suriname in 2010?
Offer a terse response. 2.74e+09. What is the difference between the Taxes (in $) in Ghana in 2009 and the Taxes (in $) in Uganda in 2010?
Your answer should be compact. -4.20e+12. What is the difference between the Taxes (in $) of Slovenia in 2009 and the Taxes (in $) of Suriname in 2010?
Give a very brief answer. 4.50e+09. What is the difference between the Taxes (in $) in Slovenia in 2009 and the Taxes (in $) in Uganda in 2010?
Your answer should be compact. -4.20e+12. What is the difference between the Taxes (in $) in Suriname in 2009 and the Taxes (in $) in Uganda in 2010?
Make the answer very short. -4.20e+12. What is the average Taxes (in $) in Ghana per year?
Your response must be concise. 3.20e+09. What is the average Taxes (in $) of Slovenia per year?
Make the answer very short. 6.23e+09. What is the average Taxes (in $) in Suriname per year?
Keep it short and to the point. 1.34e+09. What is the average Taxes (in $) in Uganda per year?
Make the answer very short. 2.60e+12. In the year 2003, what is the difference between the Taxes (in $) of Ghana and Taxes (in $) of Slovenia?
Your response must be concise. -4.00e+09. In the year 2003, what is the difference between the Taxes (in $) of Ghana and Taxes (in $) of Suriname?
Provide a short and direct response. 5.10e+08. In the year 2003, what is the difference between the Taxes (in $) of Ghana and Taxes (in $) of Uganda?
Give a very brief answer. -1.40e+12. In the year 2003, what is the difference between the Taxes (in $) of Slovenia and Taxes (in $) of Suriname?
Offer a very short reply. 4.51e+09. In the year 2003, what is the difference between the Taxes (in $) of Slovenia and Taxes (in $) of Uganda?
Ensure brevity in your answer.  -1.40e+12. In the year 2003, what is the difference between the Taxes (in $) in Suriname and Taxes (in $) in Uganda?
Provide a succinct answer. -1.40e+12. In the year 2004, what is the difference between the Taxes (in $) of Ghana and Taxes (in $) of Slovenia?
Offer a very short reply. -3.83e+09. In the year 2004, what is the difference between the Taxes (in $) in Ghana and Taxes (in $) in Suriname?
Offer a very short reply. 8.85e+08. In the year 2004, what is the difference between the Taxes (in $) in Ghana and Taxes (in $) in Uganda?
Ensure brevity in your answer.  -1.64e+12. In the year 2004, what is the difference between the Taxes (in $) in Slovenia and Taxes (in $) in Suriname?
Offer a very short reply. 4.71e+09. In the year 2004, what is the difference between the Taxes (in $) of Slovenia and Taxes (in $) of Uganda?
Provide a short and direct response. -1.64e+12. In the year 2004, what is the difference between the Taxes (in $) in Suriname and Taxes (in $) in Uganda?
Your answer should be compact. -1.64e+12. In the year 2005, what is the difference between the Taxes (in $) in Ghana and Taxes (in $) in Slovenia?
Offer a terse response. -3.83e+09. In the year 2005, what is the difference between the Taxes (in $) in Ghana and Taxes (in $) in Suriname?
Offer a very short reply. 1.07e+09. In the year 2005, what is the difference between the Taxes (in $) in Ghana and Taxes (in $) in Uganda?
Offer a very short reply. -1.89e+12. In the year 2005, what is the difference between the Taxes (in $) in Slovenia and Taxes (in $) in Suriname?
Make the answer very short. 4.89e+09. In the year 2005, what is the difference between the Taxes (in $) in Slovenia and Taxes (in $) in Uganda?
Offer a terse response. -1.88e+12. In the year 2005, what is the difference between the Taxes (in $) in Suriname and Taxes (in $) in Uganda?
Your answer should be compact. -1.89e+12. In the year 2006, what is the difference between the Taxes (in $) in Ghana and Taxes (in $) in Slovenia?
Offer a terse response. -4.12e+09. In the year 2006, what is the difference between the Taxes (in $) in Ghana and Taxes (in $) in Suriname?
Keep it short and to the point. 1.19e+09. In the year 2006, what is the difference between the Taxes (in $) of Ghana and Taxes (in $) of Uganda?
Offer a very short reply. -2.23e+12. In the year 2006, what is the difference between the Taxes (in $) of Slovenia and Taxes (in $) of Suriname?
Keep it short and to the point. 5.31e+09. In the year 2006, what is the difference between the Taxes (in $) of Slovenia and Taxes (in $) of Uganda?
Your response must be concise. -2.22e+12. In the year 2006, what is the difference between the Taxes (in $) of Suriname and Taxes (in $) of Uganda?
Provide a short and direct response. -2.23e+12. In the year 2007, what is the difference between the Taxes (in $) of Ghana and Taxes (in $) of Slovenia?
Provide a succinct answer. -3.58e+09. In the year 2007, what is the difference between the Taxes (in $) of Ghana and Taxes (in $) of Suriname?
Your answer should be compact. 1.69e+09. In the year 2007, what is the difference between the Taxes (in $) in Ghana and Taxes (in $) in Uganda?
Provide a succinct answer. -2.62e+12. In the year 2007, what is the difference between the Taxes (in $) in Slovenia and Taxes (in $) in Suriname?
Your answer should be very brief. 5.27e+09. In the year 2007, what is the difference between the Taxes (in $) of Slovenia and Taxes (in $) of Uganda?
Your response must be concise. -2.62e+12. In the year 2007, what is the difference between the Taxes (in $) in Suriname and Taxes (in $) in Uganda?
Your answer should be very brief. -2.62e+12. In the year 2008, what is the difference between the Taxes (in $) in Ghana and Taxes (in $) in Slovenia?
Keep it short and to the point. -3.24e+09. In the year 2008, what is the difference between the Taxes (in $) of Ghana and Taxes (in $) of Suriname?
Your response must be concise. 2.51e+09. In the year 2008, what is the difference between the Taxes (in $) of Ghana and Taxes (in $) of Uganda?
Offer a very short reply. -3.16e+12. In the year 2008, what is the difference between the Taxes (in $) in Slovenia and Taxes (in $) in Suriname?
Provide a short and direct response. 5.75e+09. In the year 2008, what is the difference between the Taxes (in $) of Slovenia and Taxes (in $) of Uganda?
Your response must be concise. -3.15e+12. In the year 2008, what is the difference between the Taxes (in $) of Suriname and Taxes (in $) of Uganda?
Give a very brief answer. -3.16e+12. In the year 2009, what is the difference between the Taxes (in $) of Ghana and Taxes (in $) of Slovenia?
Your response must be concise. -1.77e+09. In the year 2009, what is the difference between the Taxes (in $) in Ghana and Taxes (in $) in Suriname?
Give a very brief answer. 2.78e+09. In the year 2009, what is the difference between the Taxes (in $) in Ghana and Taxes (in $) in Uganda?
Your response must be concise. -3.66e+12. In the year 2009, what is the difference between the Taxes (in $) in Slovenia and Taxes (in $) in Suriname?
Give a very brief answer. 4.55e+09. In the year 2009, what is the difference between the Taxes (in $) of Slovenia and Taxes (in $) of Uganda?
Provide a short and direct response. -3.66e+12. In the year 2009, what is the difference between the Taxes (in $) in Suriname and Taxes (in $) in Uganda?
Your answer should be compact. -3.66e+12. In the year 2010, what is the difference between the Taxes (in $) of Ghana and Taxes (in $) of Slovenia?
Your answer should be very brief. 9.86e+07. In the year 2010, what is the difference between the Taxes (in $) of Ghana and Taxes (in $) of Suriname?
Your answer should be very brief. 4.29e+09. In the year 2010, what is the difference between the Taxes (in $) of Ghana and Taxes (in $) of Uganda?
Provide a short and direct response. -4.20e+12. In the year 2010, what is the difference between the Taxes (in $) of Slovenia and Taxes (in $) of Suriname?
Ensure brevity in your answer.  4.19e+09. In the year 2010, what is the difference between the Taxes (in $) in Slovenia and Taxes (in $) in Uganda?
Provide a succinct answer. -4.20e+12. In the year 2010, what is the difference between the Taxes (in $) in Suriname and Taxes (in $) in Uganda?
Give a very brief answer. -4.20e+12. What is the ratio of the Taxes (in $) in Ghana in 2003 to that in 2004?
Provide a succinct answer. 0.7. What is the ratio of the Taxes (in $) of Slovenia in 2003 to that in 2004?
Offer a very short reply. 0.94. What is the ratio of the Taxes (in $) in Suriname in 2003 to that in 2004?
Your answer should be very brief. 0.83. What is the ratio of the Taxes (in $) of Uganda in 2003 to that in 2004?
Keep it short and to the point. 0.85. What is the ratio of the Taxes (in $) in Ghana in 2003 to that in 2005?
Keep it short and to the point. 0.59. What is the ratio of the Taxes (in $) in Slovenia in 2003 to that in 2005?
Provide a short and direct response. 0.89. What is the ratio of the Taxes (in $) of Suriname in 2003 to that in 2005?
Offer a terse response. 0.71. What is the ratio of the Taxes (in $) of Uganda in 2003 to that in 2005?
Make the answer very short. 0.74. What is the ratio of the Taxes (in $) of Ghana in 2003 to that in 2006?
Give a very brief answer. 0.51. What is the ratio of the Taxes (in $) in Slovenia in 2003 to that in 2006?
Your response must be concise. 0.8. What is the ratio of the Taxes (in $) of Suriname in 2003 to that in 2006?
Keep it short and to the point. 0.59. What is the ratio of the Taxes (in $) of Uganda in 2003 to that in 2006?
Offer a terse response. 0.63. What is the ratio of the Taxes (in $) in Ghana in 2003 to that in 2007?
Give a very brief answer. 0.38. What is the ratio of the Taxes (in $) of Slovenia in 2003 to that in 2007?
Your answer should be very brief. 0.77. What is the ratio of the Taxes (in $) of Suriname in 2003 to that in 2007?
Keep it short and to the point. 0.47. What is the ratio of the Taxes (in $) of Uganda in 2003 to that in 2007?
Provide a succinct answer. 0.53. What is the ratio of the Taxes (in $) in Ghana in 2003 to that in 2008?
Give a very brief answer. 0.29. What is the ratio of the Taxes (in $) of Slovenia in 2003 to that in 2008?
Ensure brevity in your answer.  0.7. What is the ratio of the Taxes (in $) of Suriname in 2003 to that in 2008?
Keep it short and to the point. 0.42. What is the ratio of the Taxes (in $) in Uganda in 2003 to that in 2008?
Offer a terse response. 0.44. What is the ratio of the Taxes (in $) in Ghana in 2003 to that in 2009?
Make the answer very short. 0.26. What is the ratio of the Taxes (in $) of Slovenia in 2003 to that in 2009?
Ensure brevity in your answer.  0.82. What is the ratio of the Taxes (in $) of Suriname in 2003 to that in 2009?
Your answer should be very brief. 0.39. What is the ratio of the Taxes (in $) in Uganda in 2003 to that in 2009?
Your answer should be very brief. 0.38. What is the ratio of the Taxes (in $) in Ghana in 2003 to that in 2010?
Your answer should be very brief. 0.2. What is the ratio of the Taxes (in $) of Slovenia in 2003 to that in 2010?
Make the answer very short. 0.86. What is the ratio of the Taxes (in $) in Suriname in 2003 to that in 2010?
Your answer should be compact. 0.38. What is the ratio of the Taxes (in $) in Uganda in 2003 to that in 2010?
Make the answer very short. 0.33. What is the ratio of the Taxes (in $) of Ghana in 2004 to that in 2005?
Offer a very short reply. 0.84. What is the ratio of the Taxes (in $) in Slovenia in 2004 to that in 2005?
Make the answer very short. 0.94. What is the ratio of the Taxes (in $) of Suriname in 2004 to that in 2005?
Keep it short and to the point. 0.85. What is the ratio of the Taxes (in $) in Uganda in 2004 to that in 2005?
Your answer should be very brief. 0.87. What is the ratio of the Taxes (in $) in Ghana in 2004 to that in 2006?
Ensure brevity in your answer.  0.73. What is the ratio of the Taxes (in $) of Slovenia in 2004 to that in 2006?
Make the answer very short. 0.85. What is the ratio of the Taxes (in $) of Suriname in 2004 to that in 2006?
Provide a succinct answer. 0.71. What is the ratio of the Taxes (in $) in Uganda in 2004 to that in 2006?
Offer a terse response. 0.74. What is the ratio of the Taxes (in $) of Ghana in 2004 to that in 2007?
Your response must be concise. 0.54. What is the ratio of the Taxes (in $) of Slovenia in 2004 to that in 2007?
Ensure brevity in your answer.  0.82. What is the ratio of the Taxes (in $) of Suriname in 2004 to that in 2007?
Offer a very short reply. 0.56. What is the ratio of the Taxes (in $) of Uganda in 2004 to that in 2007?
Provide a short and direct response. 0.63. What is the ratio of the Taxes (in $) of Ghana in 2004 to that in 2008?
Your answer should be very brief. 0.41. What is the ratio of the Taxes (in $) in Slovenia in 2004 to that in 2008?
Your answer should be very brief. 0.75. What is the ratio of the Taxes (in $) of Suriname in 2004 to that in 2008?
Your answer should be very brief. 0.51. What is the ratio of the Taxes (in $) of Uganda in 2004 to that in 2008?
Your response must be concise. 0.52. What is the ratio of the Taxes (in $) of Ghana in 2004 to that in 2009?
Your answer should be compact. 0.38. What is the ratio of the Taxes (in $) in Slovenia in 2004 to that in 2009?
Ensure brevity in your answer.  0.87. What is the ratio of the Taxes (in $) in Suriname in 2004 to that in 2009?
Make the answer very short. 0.47. What is the ratio of the Taxes (in $) in Uganda in 2004 to that in 2009?
Offer a terse response. 0.45. What is the ratio of the Taxes (in $) of Ghana in 2004 to that in 2010?
Offer a terse response. 0.28. What is the ratio of the Taxes (in $) of Slovenia in 2004 to that in 2010?
Provide a short and direct response. 0.92. What is the ratio of the Taxes (in $) in Suriname in 2004 to that in 2010?
Provide a succinct answer. 0.45. What is the ratio of the Taxes (in $) in Uganda in 2004 to that in 2010?
Offer a very short reply. 0.39. What is the ratio of the Taxes (in $) in Ghana in 2005 to that in 2006?
Provide a short and direct response. 0.87. What is the ratio of the Taxes (in $) of Slovenia in 2005 to that in 2006?
Offer a very short reply. 0.91. What is the ratio of the Taxes (in $) in Suriname in 2005 to that in 2006?
Offer a terse response. 0.83. What is the ratio of the Taxes (in $) in Uganda in 2005 to that in 2006?
Your response must be concise. 0.85. What is the ratio of the Taxes (in $) of Ghana in 2005 to that in 2007?
Make the answer very short. 0.65. What is the ratio of the Taxes (in $) in Slovenia in 2005 to that in 2007?
Your answer should be compact. 0.87. What is the ratio of the Taxes (in $) of Suriname in 2005 to that in 2007?
Your response must be concise. 0.66. What is the ratio of the Taxes (in $) in Uganda in 2005 to that in 2007?
Your answer should be very brief. 0.72. What is the ratio of the Taxes (in $) of Ghana in 2005 to that in 2008?
Ensure brevity in your answer.  0.49. What is the ratio of the Taxes (in $) of Slovenia in 2005 to that in 2008?
Your answer should be compact. 0.79. What is the ratio of the Taxes (in $) of Suriname in 2005 to that in 2008?
Your answer should be compact. 0.6. What is the ratio of the Taxes (in $) of Uganda in 2005 to that in 2008?
Make the answer very short. 0.6. What is the ratio of the Taxes (in $) in Ghana in 2005 to that in 2009?
Provide a short and direct response. 0.45. What is the ratio of the Taxes (in $) of Slovenia in 2005 to that in 2009?
Provide a succinct answer. 0.92. What is the ratio of the Taxes (in $) of Suriname in 2005 to that in 2009?
Give a very brief answer. 0.55. What is the ratio of the Taxes (in $) in Uganda in 2005 to that in 2009?
Provide a short and direct response. 0.52. What is the ratio of the Taxes (in $) of Ghana in 2005 to that in 2010?
Your answer should be very brief. 0.34. What is the ratio of the Taxes (in $) in Slovenia in 2005 to that in 2010?
Your answer should be very brief. 0.97. What is the ratio of the Taxes (in $) of Suriname in 2005 to that in 2010?
Your answer should be compact. 0.54. What is the ratio of the Taxes (in $) of Uganda in 2005 to that in 2010?
Keep it short and to the point. 0.45. What is the ratio of the Taxes (in $) in Ghana in 2006 to that in 2007?
Provide a short and direct response. 0.75. What is the ratio of the Taxes (in $) of Slovenia in 2006 to that in 2007?
Offer a terse response. 0.96. What is the ratio of the Taxes (in $) in Suriname in 2006 to that in 2007?
Make the answer very short. 0.79. What is the ratio of the Taxes (in $) in Uganda in 2006 to that in 2007?
Keep it short and to the point. 0.85. What is the ratio of the Taxes (in $) of Ghana in 2006 to that in 2008?
Your answer should be very brief. 0.57. What is the ratio of the Taxes (in $) of Slovenia in 2006 to that in 2008?
Your answer should be compact. 0.88. What is the ratio of the Taxes (in $) of Suriname in 2006 to that in 2008?
Your answer should be compact. 0.72. What is the ratio of the Taxes (in $) of Uganda in 2006 to that in 2008?
Your response must be concise. 0.71. What is the ratio of the Taxes (in $) in Ghana in 2006 to that in 2009?
Your answer should be very brief. 0.52. What is the ratio of the Taxes (in $) of Slovenia in 2006 to that in 2009?
Offer a very short reply. 1.02. What is the ratio of the Taxes (in $) of Suriname in 2006 to that in 2009?
Provide a succinct answer. 0.66. What is the ratio of the Taxes (in $) of Uganda in 2006 to that in 2009?
Keep it short and to the point. 0.61. What is the ratio of the Taxes (in $) of Ghana in 2006 to that in 2010?
Make the answer very short. 0.39. What is the ratio of the Taxes (in $) in Slovenia in 2006 to that in 2010?
Offer a terse response. 1.07. What is the ratio of the Taxes (in $) of Suriname in 2006 to that in 2010?
Your answer should be very brief. 0.64. What is the ratio of the Taxes (in $) of Uganda in 2006 to that in 2010?
Give a very brief answer. 0.53. What is the ratio of the Taxes (in $) of Ghana in 2007 to that in 2008?
Give a very brief answer. 0.77. What is the ratio of the Taxes (in $) in Slovenia in 2007 to that in 2008?
Offer a very short reply. 0.91. What is the ratio of the Taxes (in $) in Suriname in 2007 to that in 2008?
Provide a short and direct response. 0.9. What is the ratio of the Taxes (in $) of Uganda in 2007 to that in 2008?
Offer a terse response. 0.83. What is the ratio of the Taxes (in $) of Ghana in 2007 to that in 2009?
Make the answer very short. 0.7. What is the ratio of the Taxes (in $) in Slovenia in 2007 to that in 2009?
Your answer should be compact. 1.06. What is the ratio of the Taxes (in $) of Suriname in 2007 to that in 2009?
Your response must be concise. 0.83. What is the ratio of the Taxes (in $) of Uganda in 2007 to that in 2009?
Ensure brevity in your answer.  0.72. What is the ratio of the Taxes (in $) in Ghana in 2007 to that in 2010?
Make the answer very short. 0.52. What is the ratio of the Taxes (in $) in Slovenia in 2007 to that in 2010?
Provide a short and direct response. 1.12. What is the ratio of the Taxes (in $) of Suriname in 2007 to that in 2010?
Provide a short and direct response. 0.81. What is the ratio of the Taxes (in $) in Uganda in 2007 to that in 2010?
Provide a short and direct response. 0.62. What is the ratio of the Taxes (in $) in Ghana in 2008 to that in 2009?
Provide a short and direct response. 0.91. What is the ratio of the Taxes (in $) of Slovenia in 2008 to that in 2009?
Your response must be concise. 1.16. What is the ratio of the Taxes (in $) in Suriname in 2008 to that in 2009?
Offer a terse response. 0.92. What is the ratio of the Taxes (in $) in Uganda in 2008 to that in 2009?
Ensure brevity in your answer.  0.86. What is the ratio of the Taxes (in $) of Ghana in 2008 to that in 2010?
Your answer should be compact. 0.68. What is the ratio of the Taxes (in $) in Slovenia in 2008 to that in 2010?
Your answer should be very brief. 1.22. What is the ratio of the Taxes (in $) in Suriname in 2008 to that in 2010?
Offer a very short reply. 0.9. What is the ratio of the Taxes (in $) of Uganda in 2008 to that in 2010?
Your answer should be compact. 0.75. What is the ratio of the Taxes (in $) in Ghana in 2009 to that in 2010?
Make the answer very short. 0.75. What is the ratio of the Taxes (in $) in Slovenia in 2009 to that in 2010?
Provide a succinct answer. 1.05. What is the ratio of the Taxes (in $) in Suriname in 2009 to that in 2010?
Make the answer very short. 0.98. What is the ratio of the Taxes (in $) of Uganda in 2009 to that in 2010?
Provide a succinct answer. 0.87. What is the difference between the highest and the second highest Taxes (in $) in Ghana?
Offer a very short reply. 1.55e+09. What is the difference between the highest and the second highest Taxes (in $) of Slovenia?
Offer a very short reply. 6.39e+08. What is the difference between the highest and the second highest Taxes (in $) of Suriname?
Your answer should be very brief. 4.60e+07. What is the difference between the highest and the second highest Taxes (in $) of Uganda?
Ensure brevity in your answer.  5.43e+11. What is the difference between the highest and the lowest Taxes (in $) in Ghana?
Give a very brief answer. 4.94e+09. What is the difference between the highest and the lowest Taxes (in $) in Slovenia?
Offer a very short reply. 2.20e+09. What is the difference between the highest and the lowest Taxes (in $) of Suriname?
Give a very brief answer. 1.17e+09. What is the difference between the highest and the lowest Taxes (in $) in Uganda?
Make the answer very short. 2.80e+12. 